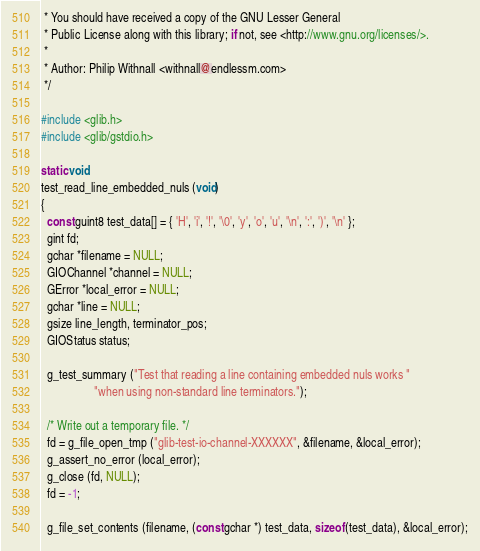Convert code to text. <code><loc_0><loc_0><loc_500><loc_500><_C_> * You should have received a copy of the GNU Lesser General
 * Public License along with this library; if not, see <http://www.gnu.org/licenses/>.
 *
 * Author: Philip Withnall <withnall@endlessm.com>
 */

#include <glib.h>
#include <glib/gstdio.h>

static void
test_read_line_embedded_nuls (void)
{
  const guint8 test_data[] = { 'H', 'i', '!', '\0', 'y', 'o', 'u', '\n', ':', ')', '\n' };
  gint fd;
  gchar *filename = NULL;
  GIOChannel *channel = NULL;
  GError *local_error = NULL;
  gchar *line = NULL;
  gsize line_length, terminator_pos;
  GIOStatus status;

  g_test_summary ("Test that reading a line containing embedded nuls works "
                  "when using non-standard line terminators.");

  /* Write out a temporary file. */
  fd = g_file_open_tmp ("glib-test-io-channel-XXXXXX", &filename, &local_error);
  g_assert_no_error (local_error);
  g_close (fd, NULL);
  fd = -1;

  g_file_set_contents (filename, (const gchar *) test_data, sizeof (test_data), &local_error);</code> 